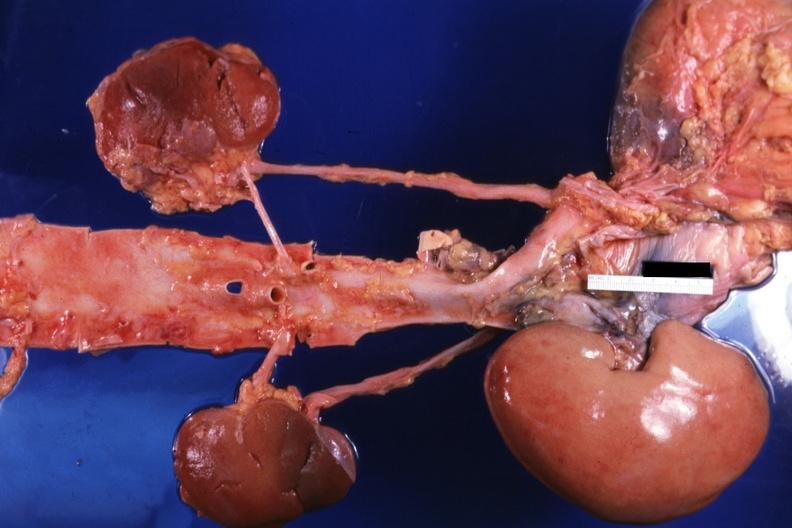what does this image show?
Answer the question using a single word or phrase. Aorta native kidneys ureters and pelvic transplant laid out to show where the transplant is placed relative to other structures 